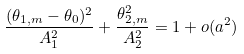<formula> <loc_0><loc_0><loc_500><loc_500>\frac { ( \theta _ { 1 , m } - \theta _ { 0 } ) ^ { 2 } } { A _ { 1 } ^ { 2 } } + \frac { \theta _ { 2 , m } ^ { 2 } } { A _ { 2 } ^ { 2 } } = 1 + o ( a ^ { 2 } )</formula> 